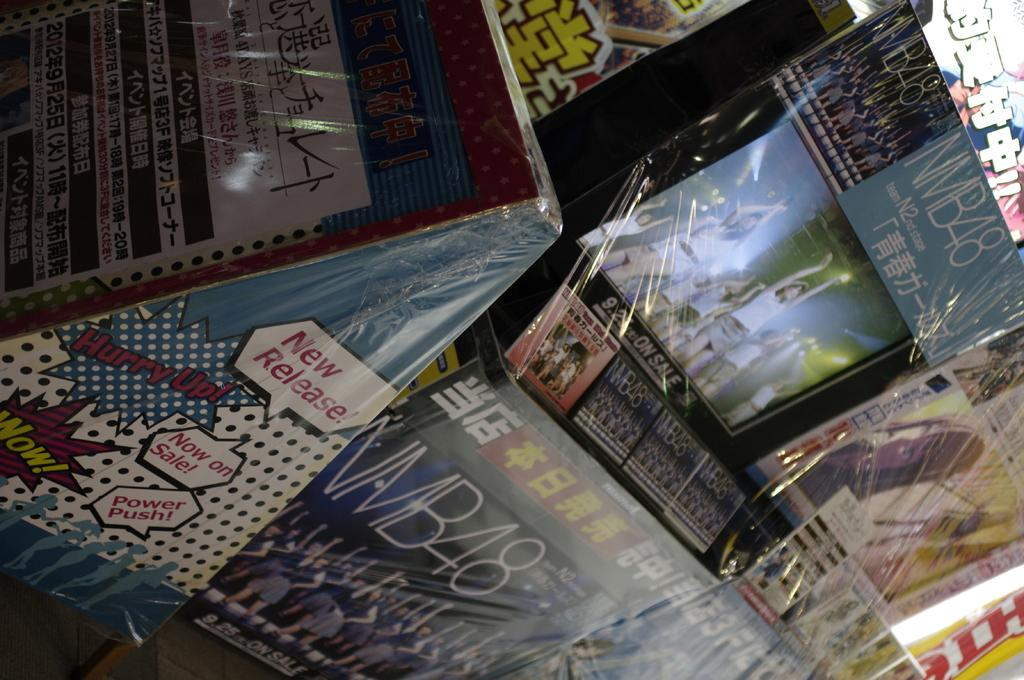<image>
Relay a brief, clear account of the picture shown. Some shrink wrapped products feature graphics proclaiming Wow! and Now on Sale! 